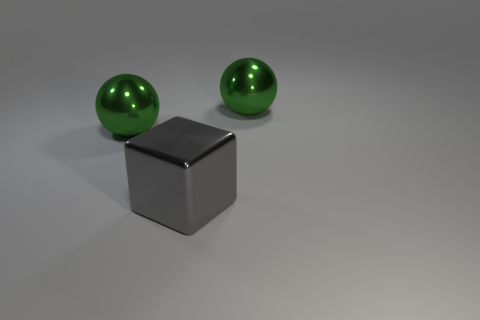The large object that is left of the large metal block is what color?
Offer a terse response. Green. What number of objects are in front of the sphere that is left of the big green metal object to the right of the big gray thing?
Offer a very short reply. 1. There is a big green metallic thing on the left side of the big gray shiny object; how many large spheres are on the right side of it?
Ensure brevity in your answer.  1. What number of big spheres are behind the gray shiny cube?
Provide a succinct answer. 2. How many other things are the same size as the gray metal block?
Ensure brevity in your answer.  2. The large green metal thing on the right side of the big gray thing has what shape?
Give a very brief answer. Sphere. There is a big ball in front of the large green object that is to the right of the big gray metal cube; what color is it?
Your answer should be very brief. Green. How many things are either large green objects right of the big gray object or large green shiny things?
Ensure brevity in your answer.  2. There is a gray thing; is it the same size as the green metallic sphere to the right of the big block?
Keep it short and to the point. Yes. How many tiny things are either green metal balls or metallic blocks?
Provide a succinct answer. 0. 